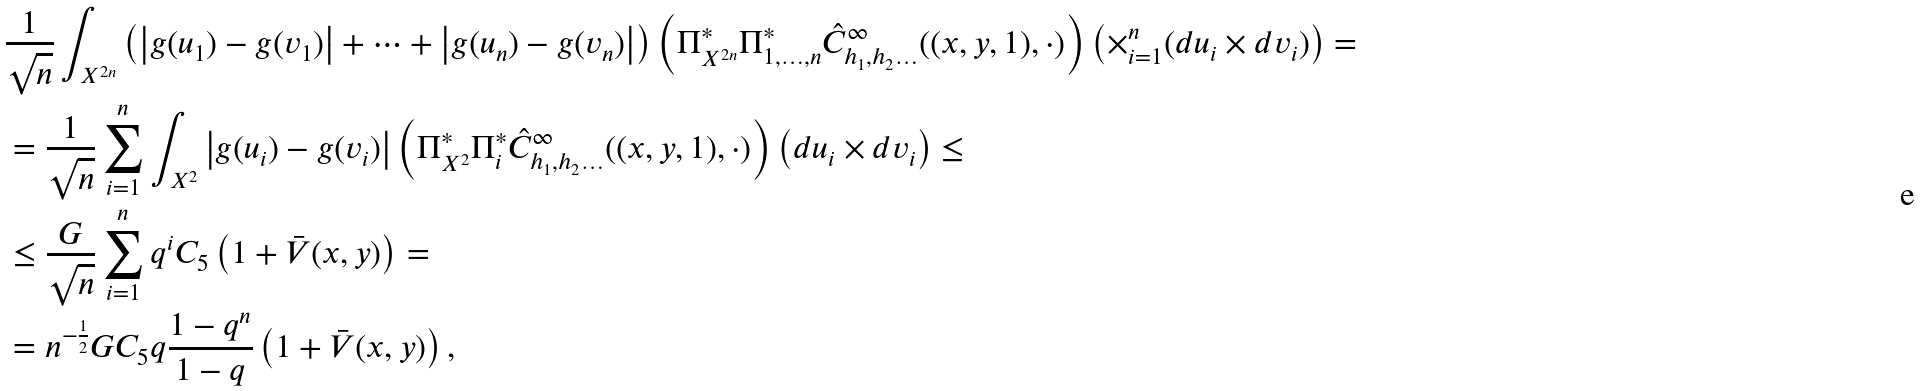Convert formula to latex. <formula><loc_0><loc_0><loc_500><loc_500>& \frac { 1 } { \sqrt { n } } \int _ { X ^ { 2 n } } \left ( \left | g ( u _ { 1 } ) - g ( v _ { 1 } ) \right | + \dots + \left | g ( u _ { n } ) - g ( v _ { n } ) \right | \right ) \left ( \Pi ^ { * } _ { X ^ { 2 n } } \Pi ^ { * } _ { 1 , \dots , n } \hat { C } ^ { \infty } _ { h _ { 1 } , h _ { 2 } \dots } ( ( x , y , 1 ) , \cdot ) \right ) \left ( \times _ { i = 1 } ^ { n } ( d u _ { i } \times d v _ { i } ) \right ) = \\ & = \frac { 1 } { \sqrt { n } } \sum _ { i = 1 } ^ { n } \int _ { X ^ { 2 } } \left | g ( u _ { i } ) - g ( v _ { i } ) \right | \left ( \Pi ^ { * } _ { X ^ { 2 } } \Pi ^ { * } _ { i } \hat { C } ^ { \infty } _ { h _ { 1 } , h _ { 2 } \dots } ( ( x , y , 1 ) , \cdot ) \right ) \left ( d u _ { i } \times d v _ { i } \right ) \leq \\ & \leq \frac { G } { \sqrt { n } } \sum _ { i = 1 } ^ { n } q ^ { i } C _ { 5 } \left ( 1 + \bar { V } ( x , y ) \right ) = \\ & = n ^ { - \frac { 1 } { 2 } } G C _ { 5 } q \frac { 1 - q ^ { n } } { 1 - q } \left ( 1 + \bar { V } ( x , y ) \right ) ,</formula> 